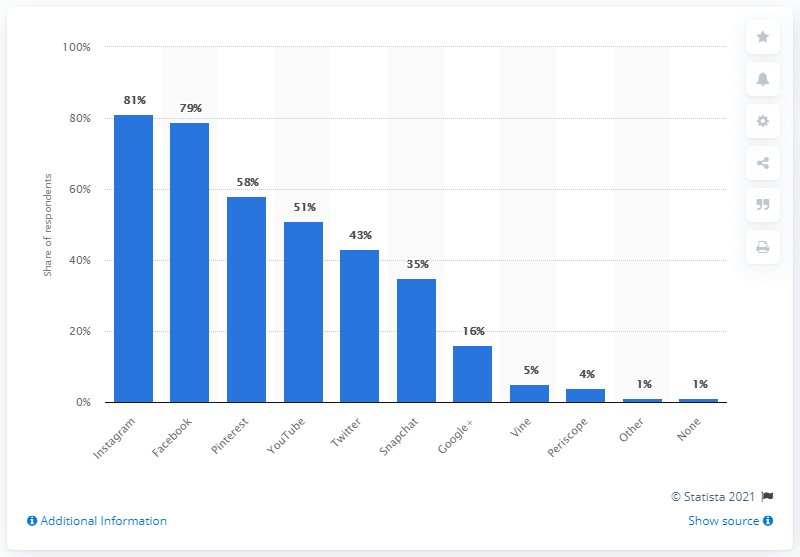List a handful of essential elements in this visual. Instagram was the most popular social platform for engaging with brand content in the past year. 